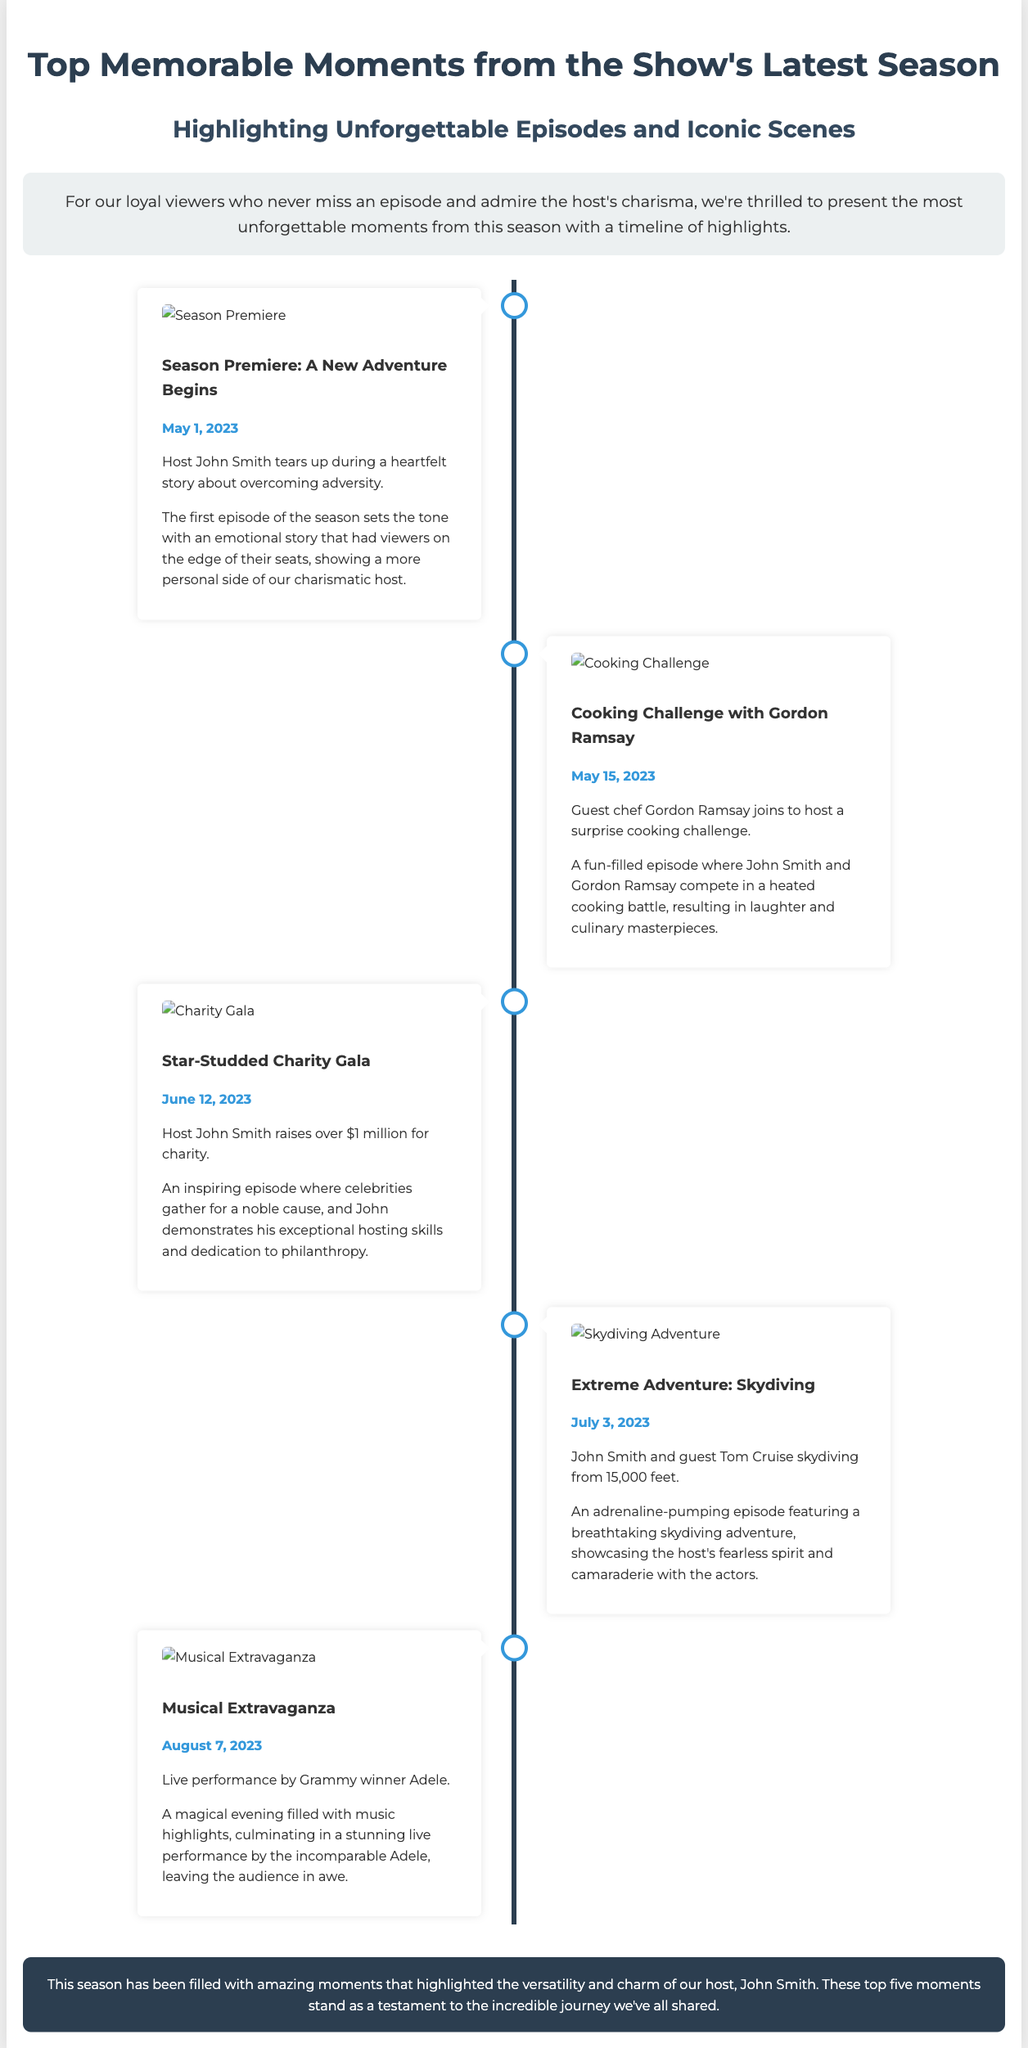What date did the season premiere air? The season premiere aired on May 1, 2023, as indicated in the timeline highlights.
Answer: May 1, 2023 Who was the guest chef in the cooking challenge? The guest chef who participated in the cooking challenge was Gordon Ramsay, as mentioned in the moment's description.
Answer: Gordon Ramsay How much money did John Smith raise for charity during the gala? John Smith raised over $1 million for charity, which is noted in the description of the charity gala moment.
Answer: Over $1 million What was the title of the episode featuring Adele? The episode featuring Adele is titled "Musical Extravaganza," as stated in the corresponding moment section.
Answer: Musical Extravaganza What type of adventure did John Smith undertake on July 3, 2023? John Smith undertook a skydiving adventure, which is mentioned in the timeline highlights.
Answer: Skydiving Which iconic actor joined John Smith for the extreme adventure? The iconic actor who joined John Smith for the extreme adventure was Tom Cruise, as highlighted in the skydiving moment.
Answer: Tom Cruise What main theme connects the featured memorable moments? The main theme that connects the featured memorable moments is the showcase of John Smith's charisma and versatility as a host.
Answer: John Smith's charisma and versatility What was the overall tone of the season premiere episode? The overall tone of the season premiere episode was emotional, as described in the summary for that moment.
Answer: Emotional 